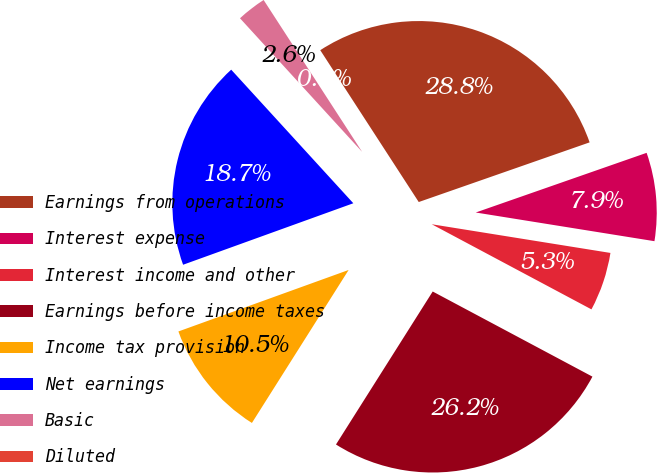Convert chart. <chart><loc_0><loc_0><loc_500><loc_500><pie_chart><fcel>Earnings from operations<fcel>Interest expense<fcel>Interest income and other<fcel>Earnings before income taxes<fcel>Income tax provision<fcel>Net earnings<fcel>Basic<fcel>Diluted<nl><fcel>28.81%<fcel>7.88%<fcel>5.26%<fcel>26.18%<fcel>10.51%<fcel>18.73%<fcel>2.63%<fcel>0.0%<nl></chart> 